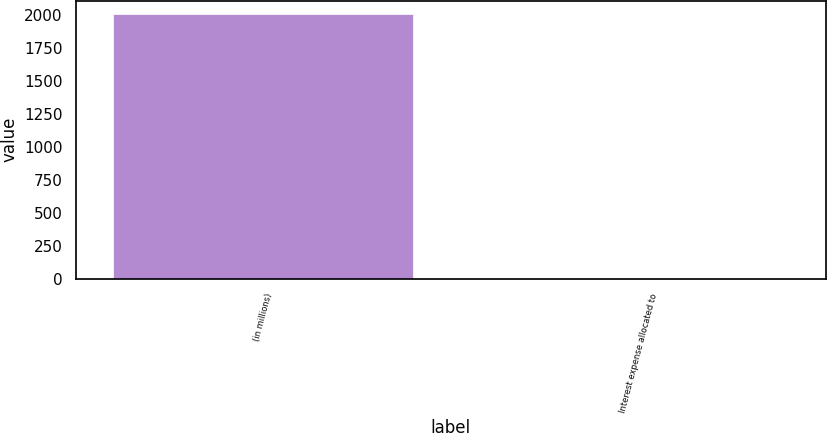Convert chart. <chart><loc_0><loc_0><loc_500><loc_500><bar_chart><fcel>(in millions)<fcel>Interest expense allocated to<nl><fcel>2011<fcel>3.33<nl></chart> 